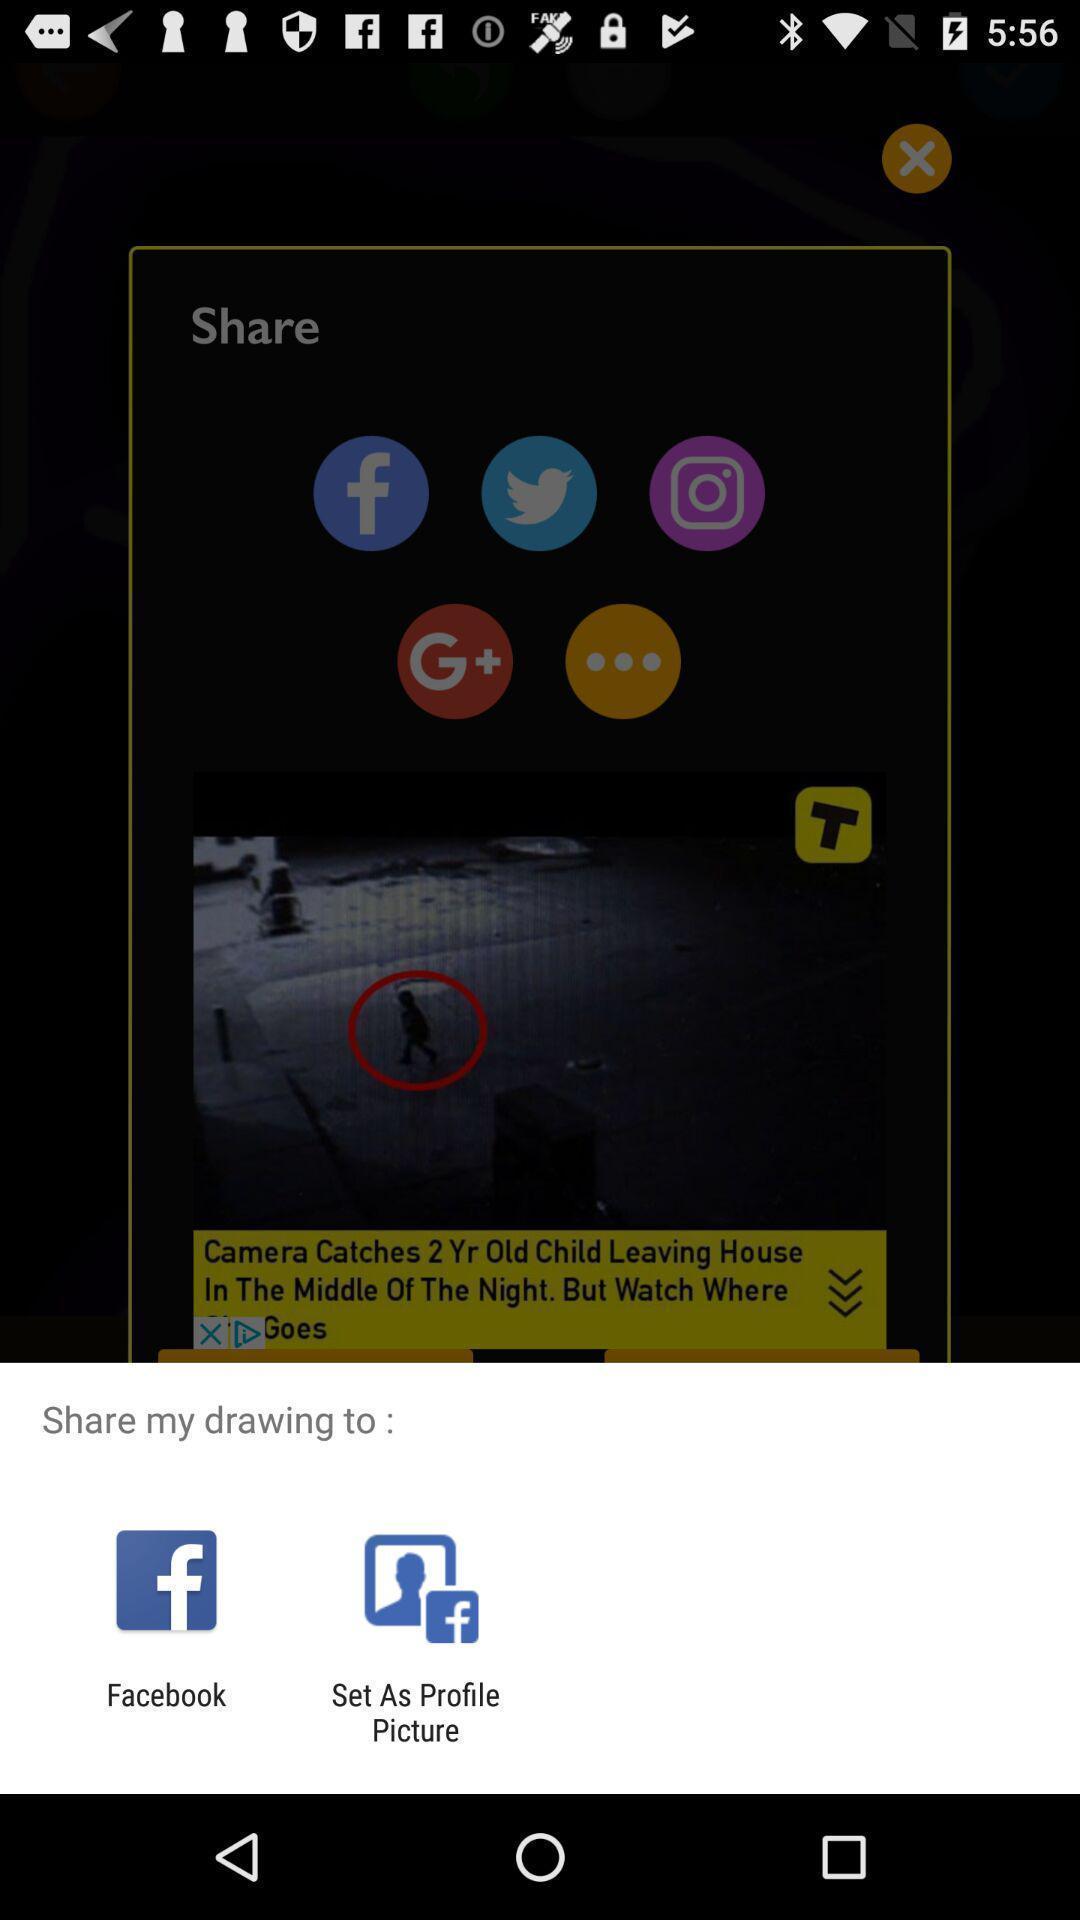Provide a description of this screenshot. Widget showing two sharing options of a social app. 